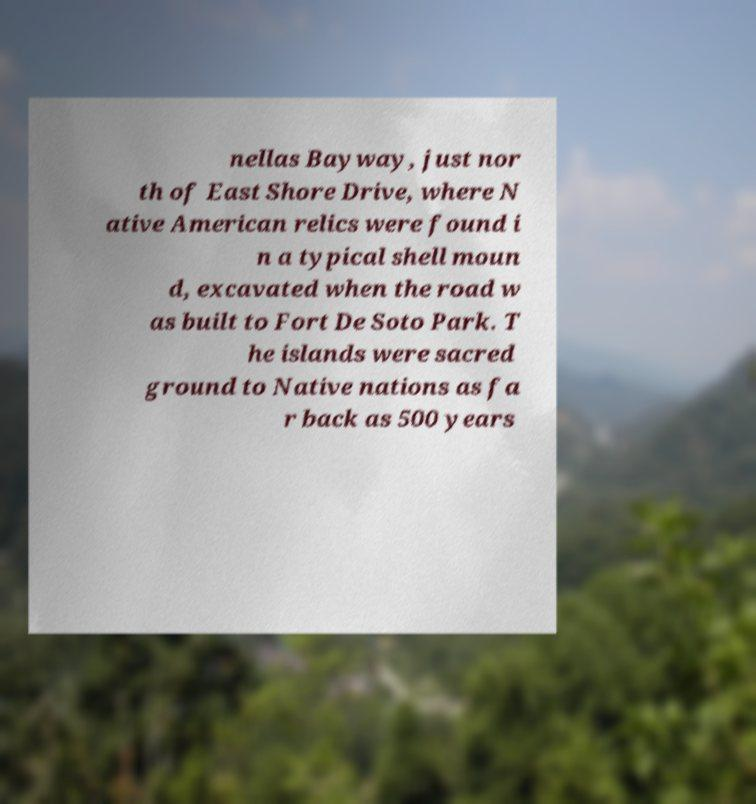I need the written content from this picture converted into text. Can you do that? nellas Bayway, just nor th of East Shore Drive, where N ative American relics were found i n a typical shell moun d, excavated when the road w as built to Fort De Soto Park. T he islands were sacred ground to Native nations as fa r back as 500 years 